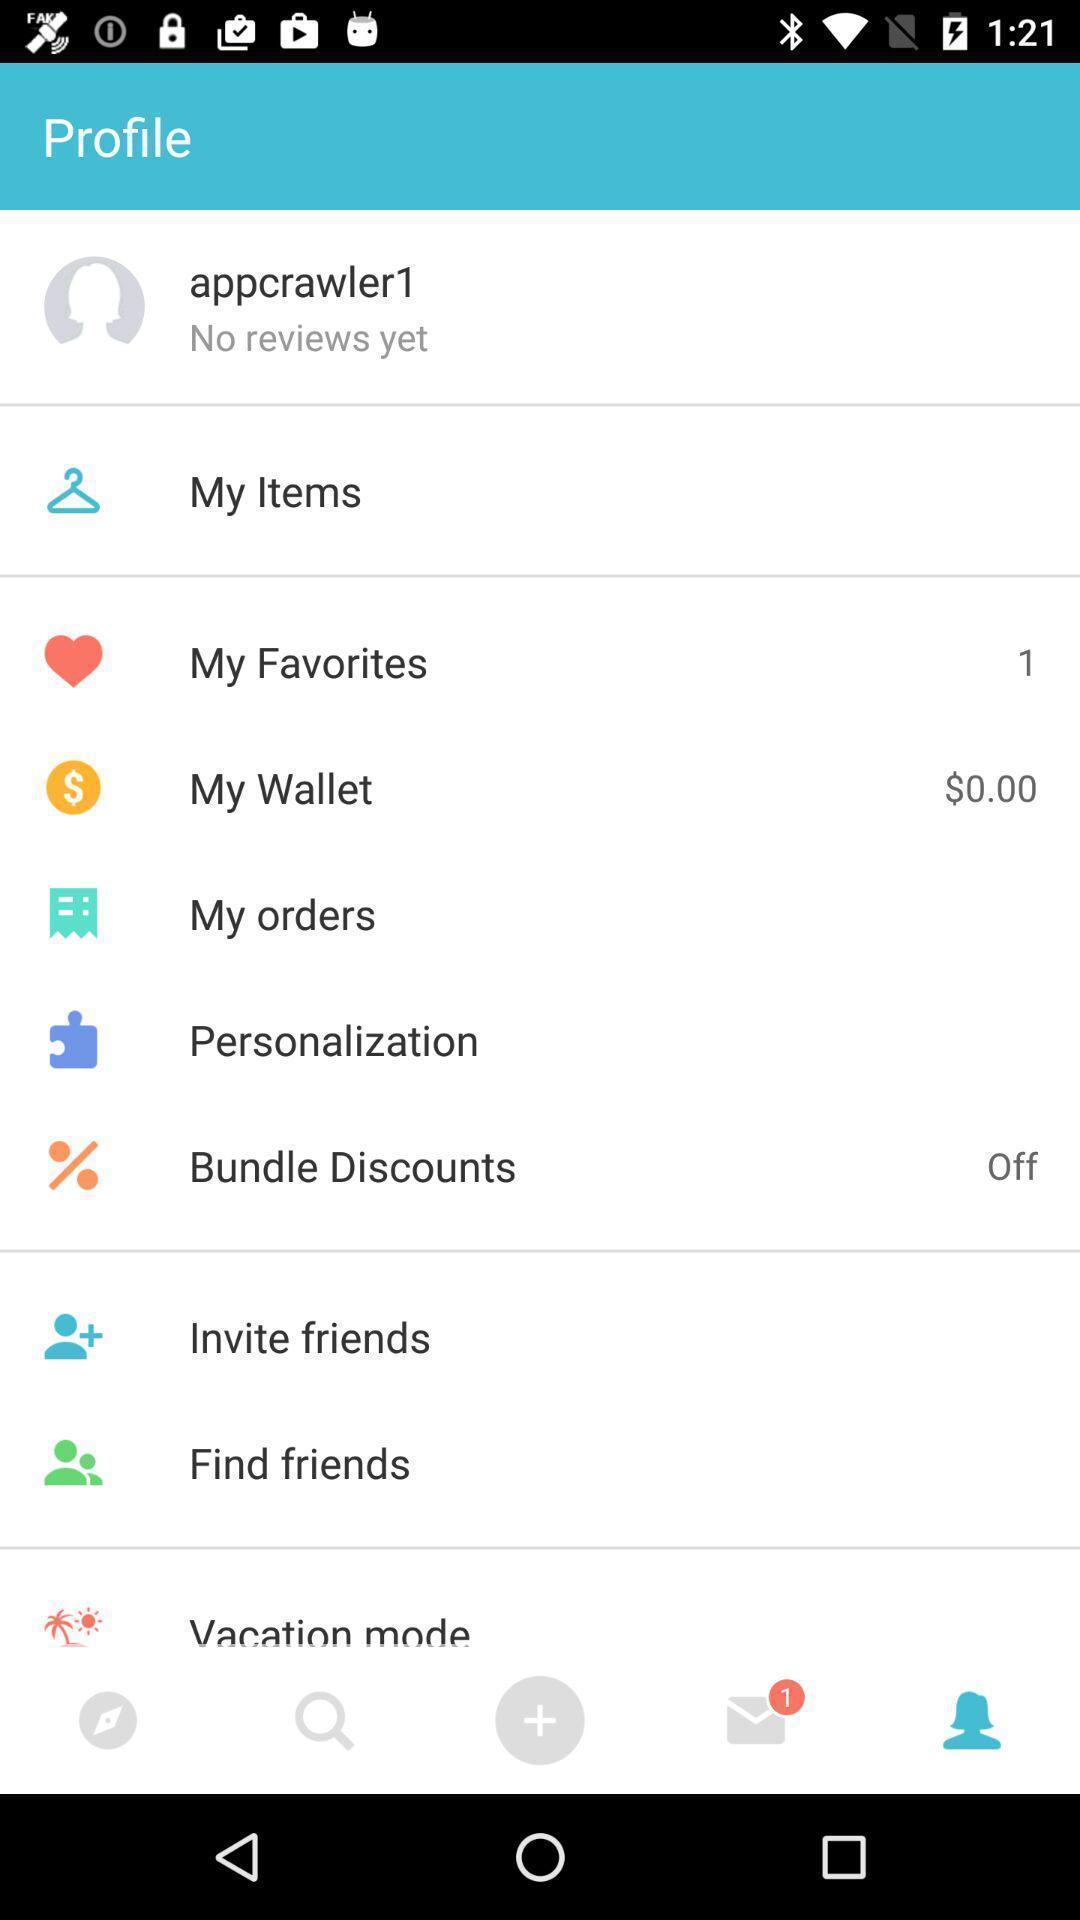Tell me about the visual elements in this screen capture. Shopping app displayed menu with different categories. 